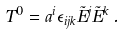<formula> <loc_0><loc_0><loc_500><loc_500>T ^ { 0 } = a ^ { i } \epsilon _ { i j k } \tilde { E } ^ { j } \tilde { E } ^ { k } \, .</formula> 